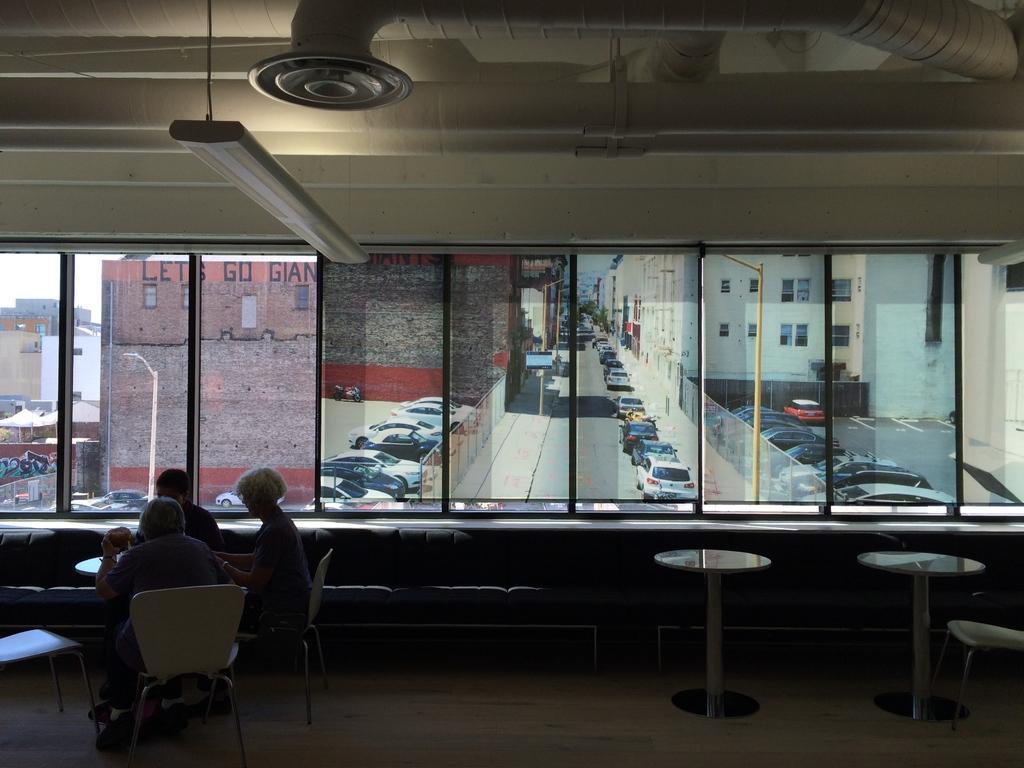Could you give a brief overview of what you see in this image? This image is an inside picture of a room. There are tables. There are people sitting on chairs. In the background of the image there is a glass window through which we can see buildings, cars, road. 